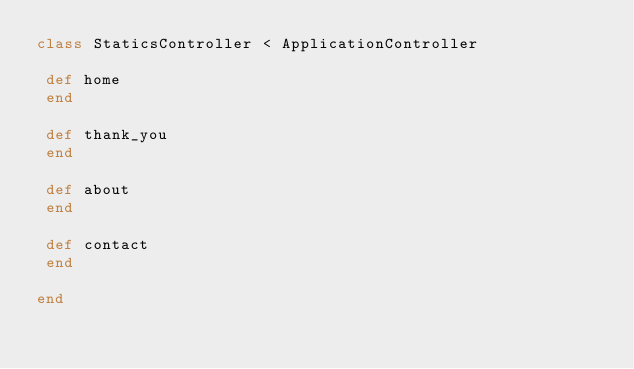Convert code to text. <code><loc_0><loc_0><loc_500><loc_500><_Ruby_>class StaticsController < ApplicationController
 
 def home
 end
  
 def thank_you
 end
 
 def about
 end
 
 def contact
 end
 
end
</code> 